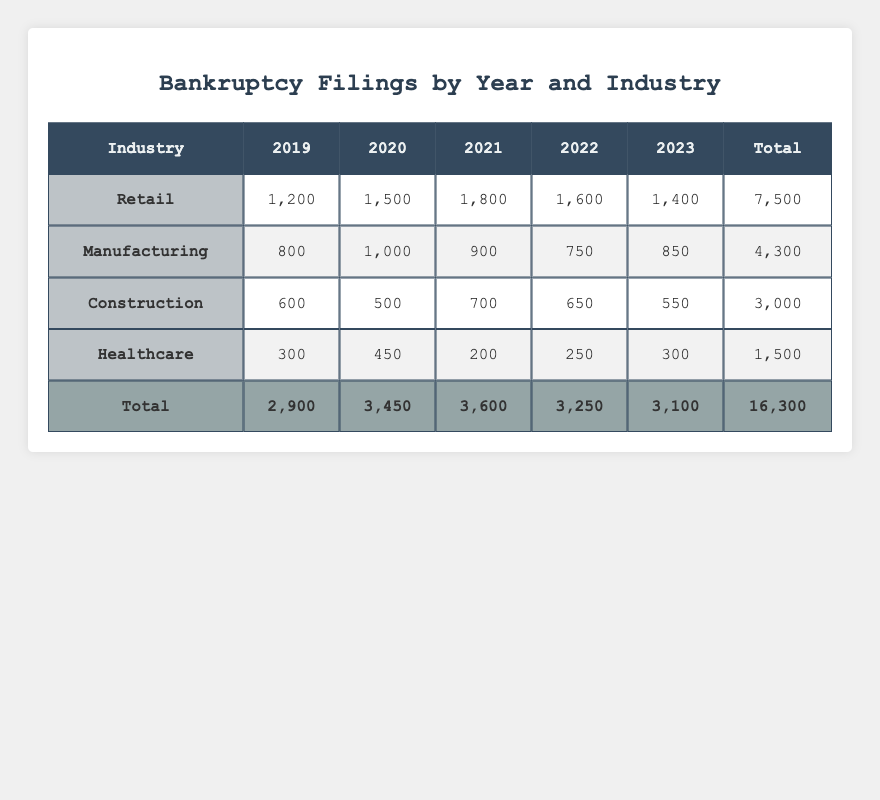What was the total number of bankruptcy filings in 2020? In the table, we can find the total number of bankruptcy filings for 2020 by looking at the "Total" row under the 2020 column. The total is listed as 3,450.
Answer: 3,450 Which industry had the highest number of bankruptcy filings in 2021? By examining the 2021 column for each industry, the Retail industry has the highest filing count listed at 1,800.
Answer: Retail What is the cumulative bankruptcy filing count for the Healthcare industry from 2019 to 2023? To calculate this, we need to sum the filing counts from the Healthcare row across the years: 300 (2019) + 450 (2020) + 200 (2021) + 250 (2022) + 300 (2023) = 1,500.
Answer: 1,500 Did the Manufacturing industry see an increase in bankruptcy filings from 2019 to 2020? By comparing the filing counts, we see 800 in 2019 and 1,000 in 2020, which is an increase. Therefore, the statement is true.
Answer: Yes What was the average number of bankruptcy filings for the Construction industry over the five years? The total bankruptcy filings for Construction across the years are 600 + 500 + 700 + 650 + 550 = 3,000. To find the average, we divide this by the number of years, which is 5. Therefore, 3,000 / 5 = 600.
Answer: 600 Which year recorded the lowest total bankruptcy filings overall? To find this, we compare the total numbers for all the years: 2,900 (2019), 3,450 (2020), 3,600 (2021), 3,250 (2022), and 3,100 (2023). The lowest is in 2019.
Answer: 2019 Was there a year when the Retail industry had fewer filings than the Manufacturing industry? By examining the years, we see that in 2020 and 2021, Retail had more filings (1,500 & 1,800) compared to Manufacturing (1,000 & 900), but in no year did Retail have fewer than Manufacturing. Therefore, the statement is false.
Answer: No What is the total number of bankruptcy filings in the table? To find the overall total, we can look at the "Total" row in the table, which sums up all industries across all years, and it shows 16,300.
Answer: 16,300 